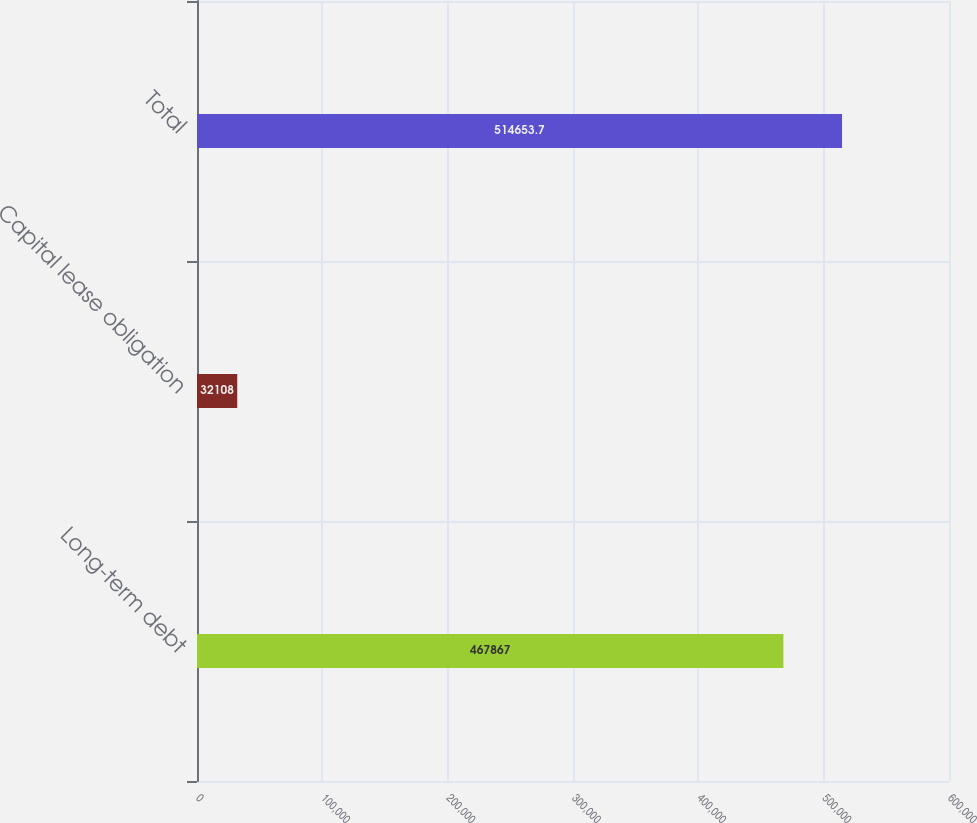<chart> <loc_0><loc_0><loc_500><loc_500><bar_chart><fcel>Long-term debt<fcel>Capital lease obligation<fcel>Total<nl><fcel>467867<fcel>32108<fcel>514654<nl></chart> 